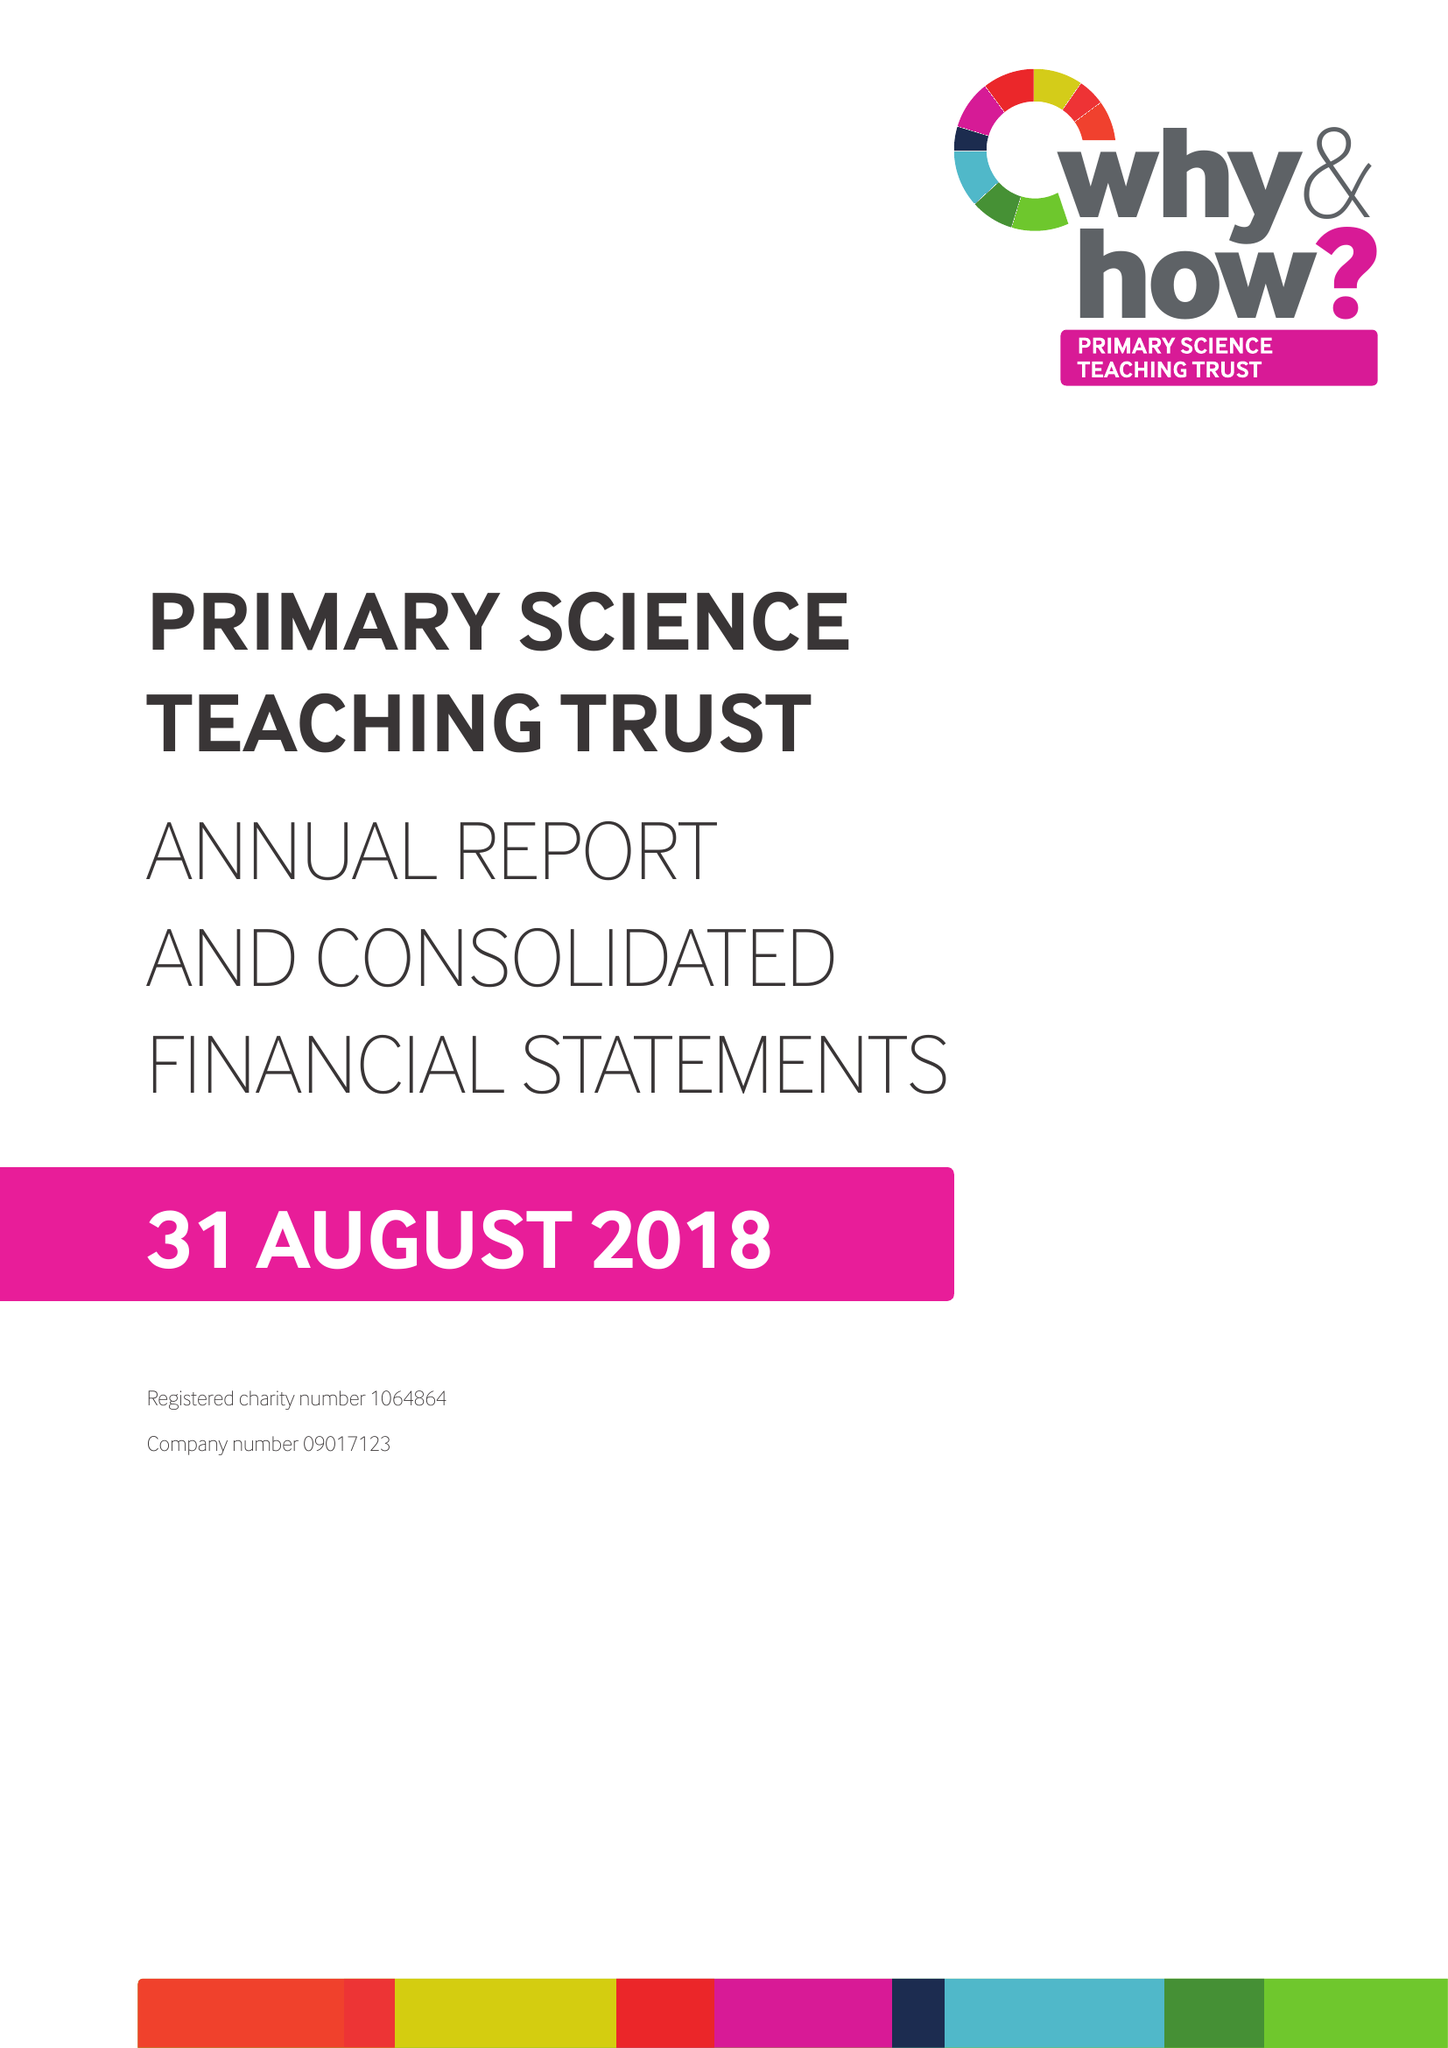What is the value for the charity_name?
Answer the question using a single word or phrase. Primary Science Teaching Trust 